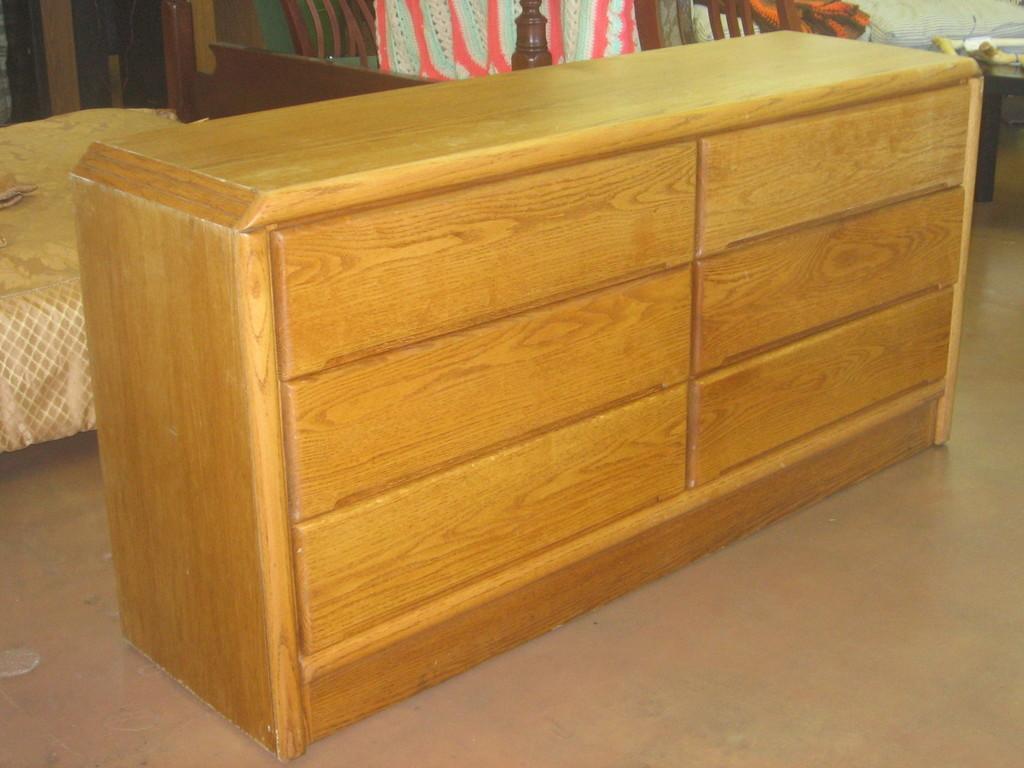Can you describe this image briefly? In the center of the image we can see a wooden stand. On the left there is a bed and we can see chairs. On the right there is a table and we can see things placed on the table. At the bottom there is a floor and we can see a cloth. 